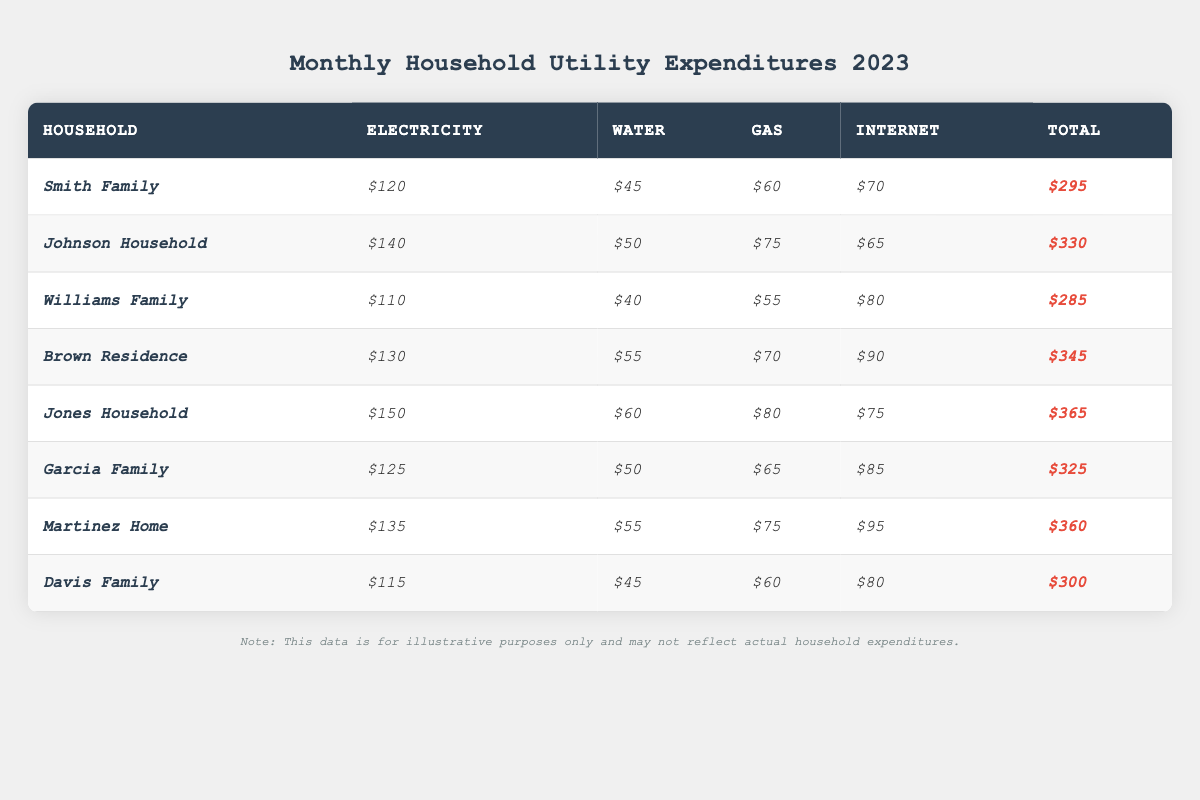What is the total expenditure for the Jones Household? Looking at the row for the Jones Household, the total expenditure is listed as $365.
Answer: $365 Which household has the highest expenditures on electricity? By examining the electricity expenses for each household, the Jones Household has the highest at $150.
Answer: Jones Household What is the difference in total expenditures between the Brown Residence and the Williams Family? The total expenditures for the Brown Residence are $345 and for the Williams Family are $285. The difference is $345 - $285 = $60.
Answer: $60 How much does the Garcia Family spend on internet compared to the Davis Family? The Garcia Family spends $85 on internet, while the Davis Family spends $80. The difference is $85 - $80 = $5.
Answer: $5 Is the total expenditure for the Smith Family greater than $300? The total expenditure for the Smith Family is $295, which is less than $300.
Answer: No What is the average total expenditure of all households listed in the table? First, we sum the total expenditures: $295 + $330 + $285 + $345 + $365 + $325 + $360 + $300 = $2,205. There are 8 households, so the average is $2,205 / 8 = $275.625.
Answer: $275.63 Which household has the lowest expenditure on water? Checking the water expenses, the Williams Family has the lowest water expenditure of $40.
Answer: Williams Family If the Johnson Household reduced its total expenditure by 10%, what would the new total be? The current total for the Johnson Household is $330. Reducing this by 10% means subtracting $330 * 0.10 = $33. The new total would be $330 - $33 = $297.
Answer: $297 What is the total amount spent on gas by all households together? Summing the gas expenditures: $60 + $75 + $55 + $70 + $80 + $65 + $75 + $60 = $570.
Answer: $570 Which two households have a combined total expenditure of $605? The Johnson Household has a total of $330 and the Williams Family has $285. Adding these gives $330 + $285 = $615. However, the Smith Family ($295) and the Brown Residence ($345) total $640. Upon checking, no exact pair totals $605.
Answer: None 